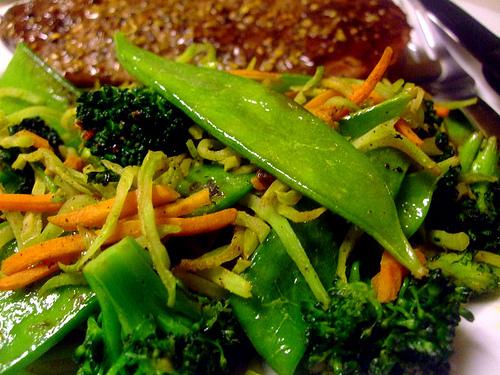What type of meat is behind the veggies?
Answer briefly. Beef. How does it taste?
Quick response, please. Good. What is the dressing of the salad?
Answer briefly. Oil. 